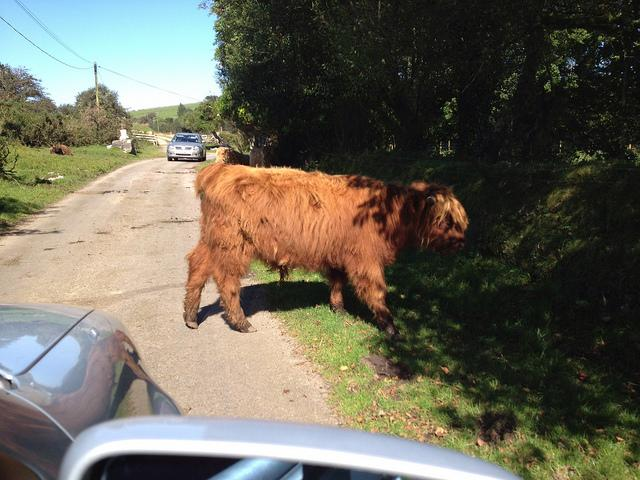What type of animal is shown? cow 